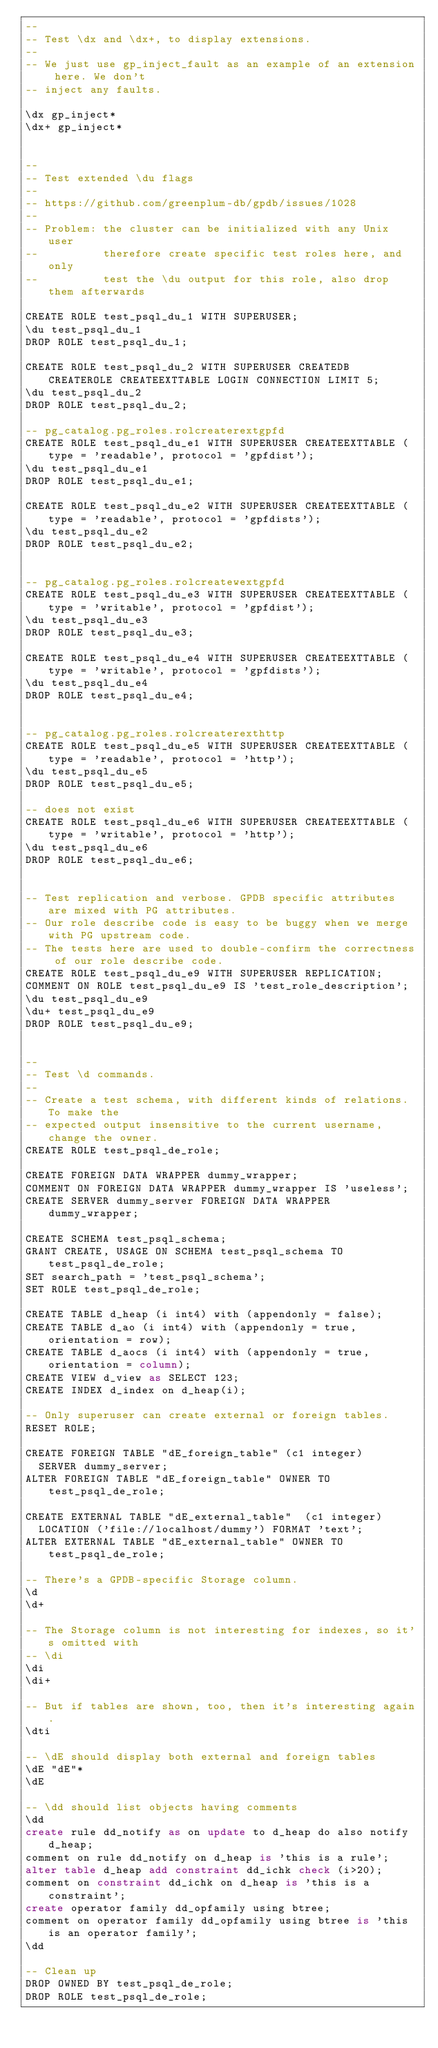<code> <loc_0><loc_0><loc_500><loc_500><_SQL_>--
-- Test \dx and \dx+, to display extensions.
--
-- We just use gp_inject_fault as an example of an extension here. We don't
-- inject any faults.

\dx gp_inject*
\dx+ gp_inject*


--
-- Test extended \du flags
--
-- https://github.com/greenplum-db/gpdb/issues/1028
--
-- Problem: the cluster can be initialized with any Unix user
--          therefore create specific test roles here, and only
--          test the \du output for this role, also drop them afterwards

CREATE ROLE test_psql_du_1 WITH SUPERUSER;
\du test_psql_du_1
DROP ROLE test_psql_du_1;

CREATE ROLE test_psql_du_2 WITH SUPERUSER CREATEDB CREATEROLE CREATEEXTTABLE LOGIN CONNECTION LIMIT 5;
\du test_psql_du_2
DROP ROLE test_psql_du_2;

-- pg_catalog.pg_roles.rolcreaterextgpfd
CREATE ROLE test_psql_du_e1 WITH SUPERUSER CREATEEXTTABLE (type = 'readable', protocol = 'gpfdist');
\du test_psql_du_e1
DROP ROLE test_psql_du_e1;

CREATE ROLE test_psql_du_e2 WITH SUPERUSER CREATEEXTTABLE (type = 'readable', protocol = 'gpfdists');
\du test_psql_du_e2
DROP ROLE test_psql_du_e2;


-- pg_catalog.pg_roles.rolcreatewextgpfd
CREATE ROLE test_psql_du_e3 WITH SUPERUSER CREATEEXTTABLE (type = 'writable', protocol = 'gpfdist');
\du test_psql_du_e3
DROP ROLE test_psql_du_e3;

CREATE ROLE test_psql_du_e4 WITH SUPERUSER CREATEEXTTABLE (type = 'writable', protocol = 'gpfdists');
\du test_psql_du_e4
DROP ROLE test_psql_du_e4;


-- pg_catalog.pg_roles.rolcreaterexthttp
CREATE ROLE test_psql_du_e5 WITH SUPERUSER CREATEEXTTABLE (type = 'readable', protocol = 'http');
\du test_psql_du_e5
DROP ROLE test_psql_du_e5;

-- does not exist
CREATE ROLE test_psql_du_e6 WITH SUPERUSER CREATEEXTTABLE (type = 'writable', protocol = 'http');
\du test_psql_du_e6
DROP ROLE test_psql_du_e6;


-- Test replication and verbose. GPDB specific attributes are mixed with PG attributes.
-- Our role describe code is easy to be buggy when we merge with PG upstream code.
-- The tests here are used to double-confirm the correctness of our role describe code.
CREATE ROLE test_psql_du_e9 WITH SUPERUSER REPLICATION;
COMMENT ON ROLE test_psql_du_e9 IS 'test_role_description';
\du test_psql_du_e9
\du+ test_psql_du_e9
DROP ROLE test_psql_du_e9;


--
-- Test \d commands.
--
-- Create a test schema, with different kinds of relations. To make the
-- expected output insensitive to the current username, change the owner.
CREATE ROLE test_psql_de_role;

CREATE FOREIGN DATA WRAPPER dummy_wrapper;
COMMENT ON FOREIGN DATA WRAPPER dummy_wrapper IS 'useless';
CREATE SERVER dummy_server FOREIGN DATA WRAPPER dummy_wrapper;

CREATE SCHEMA test_psql_schema;
GRANT CREATE, USAGE ON SCHEMA test_psql_schema TO test_psql_de_role;
SET search_path = 'test_psql_schema';
SET ROLE test_psql_de_role;

CREATE TABLE d_heap (i int4) with (appendonly = false);
CREATE TABLE d_ao (i int4) with (appendonly = true, orientation = row);
CREATE TABLE d_aocs (i int4) with (appendonly = true, orientation = column);
CREATE VIEW d_view as SELECT 123;
CREATE INDEX d_index on d_heap(i);

-- Only superuser can create external or foreign tables.
RESET ROLE;

CREATE FOREIGN TABLE "dE_foreign_table" (c1 integer)
  SERVER dummy_server;
ALTER FOREIGN TABLE "dE_foreign_table" OWNER TO test_psql_de_role;

CREATE EXTERNAL TABLE "dE_external_table"  (c1 integer)
  LOCATION ('file://localhost/dummy') FORMAT 'text';
ALTER EXTERNAL TABLE "dE_external_table" OWNER TO test_psql_de_role;

-- There's a GPDB-specific Storage column.
\d
\d+

-- The Storage column is not interesting for indexes, so it's omitted with
-- \di
\di
\di+

-- But if tables are shown, too, then it's interesting again.
\dti

-- \dE should display both external and foreign tables
\dE "dE"*
\dE

-- \dd should list objects having comments
\dd
create rule dd_notify as on update to d_heap do also notify d_heap;
comment on rule dd_notify on d_heap is 'this is a rule';
alter table d_heap add constraint dd_ichk check (i>20);
comment on constraint dd_ichk on d_heap is 'this is a constraint';
create operator family dd_opfamily using btree;
comment on operator family dd_opfamily using btree is 'this is an operator family';
\dd

-- Clean up
DROP OWNED BY test_psql_de_role;
DROP ROLE test_psql_de_role;
</code> 